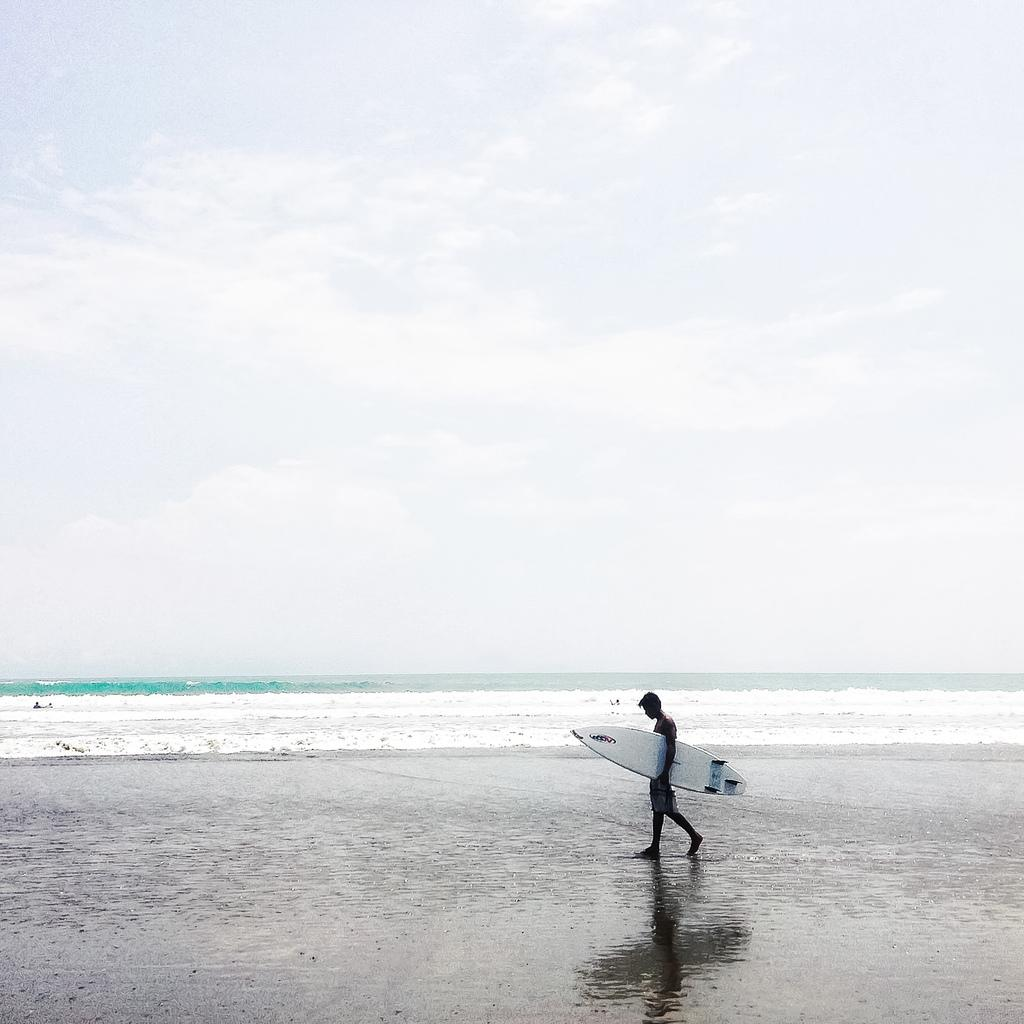What is the man in the image holding? The man is holding a ski board in the image. Can you describe the background of the image? There is water and the sky visible in the background of the image. What type of advice is the coach giving to the man in the image? There is no coach present in the image, and therefore no advice-giving can be observed. What is the man using to paste something on the ski board? There is no paste or any indication of pasting something on the ski board in the image. 